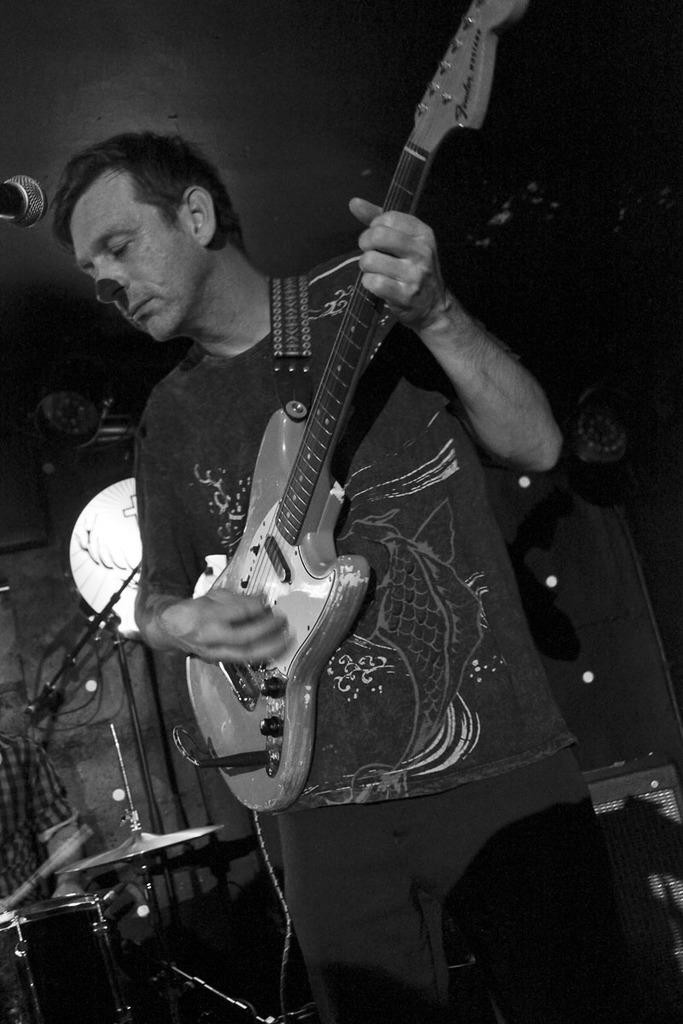What is the main subject of the image? There is a person in the image. What is the person doing in the image? The person is standing in the image. What object is the person holding in the image? The person is holding a guitar in the image. How many dogs are playing with dolls on the hill in the image? There are no dogs, dolls dolls, or hills present in the image. 